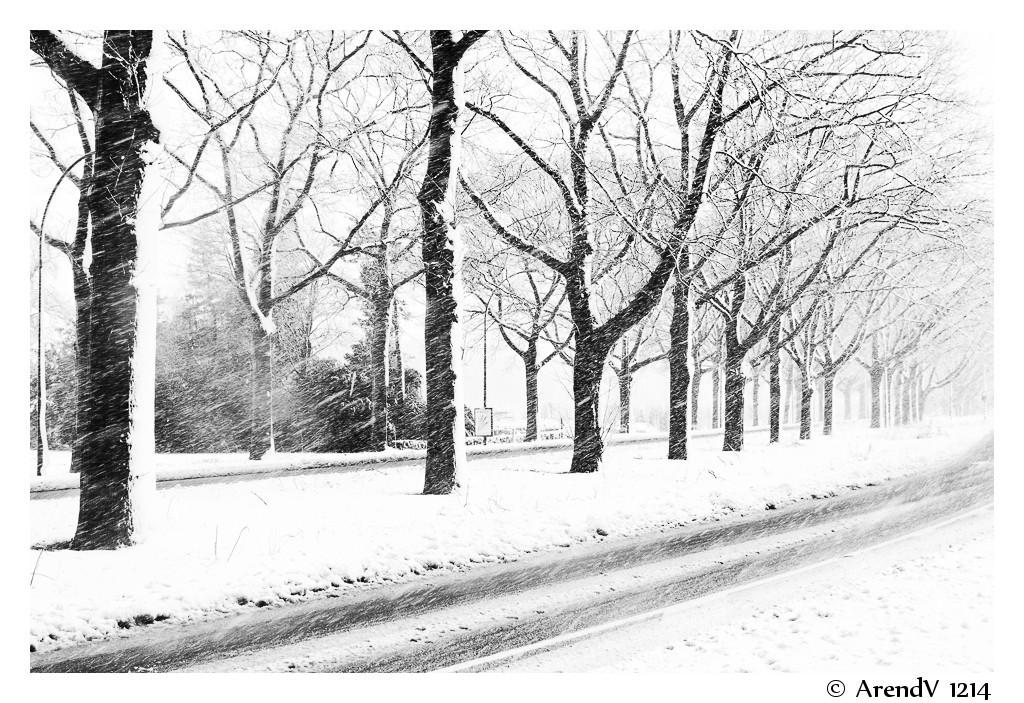What type of vegetation can be seen in the image? There are trees in the image. What is the condition of the trees in the image? The trees are covered in snow. What is located at the bottom of the image? There is a road at the bottom of the image. What type of design can be seen on the pocket of the person in the image? There is no person present in the image, so there is no pocket or design to observe. 